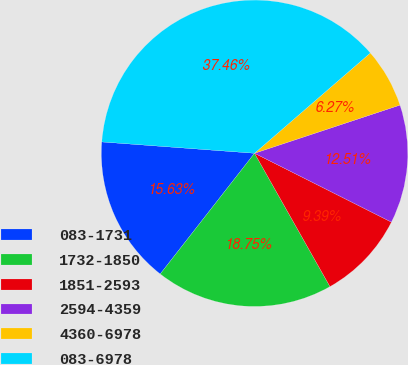Convert chart to OTSL. <chart><loc_0><loc_0><loc_500><loc_500><pie_chart><fcel>083-1731<fcel>1732-1850<fcel>1851-2593<fcel>2594-4359<fcel>4360-6978<fcel>083-6978<nl><fcel>15.63%<fcel>18.75%<fcel>9.39%<fcel>12.51%<fcel>6.27%<fcel>37.47%<nl></chart> 